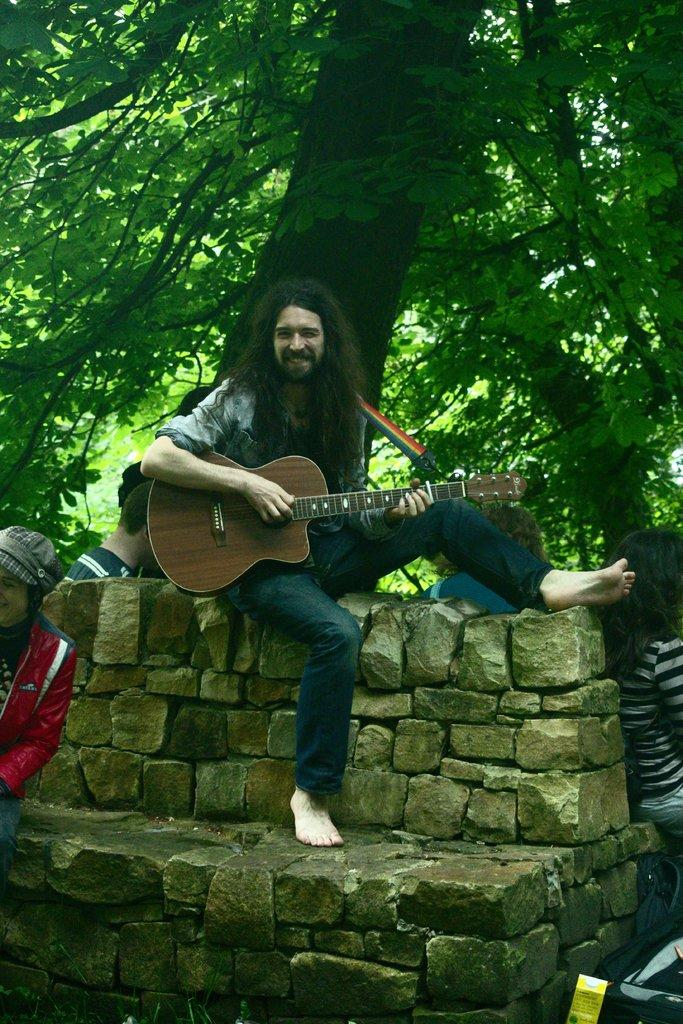What is the person in the image doing? The person is playing a guitar. What type of clothing is the person wearing? The person is wearing black jeans. Where is the person sitting in the image? The person is sitting on a stone wall. Are there any other people in the image? Yes, there is a group of people around the person. What can be seen in the background of the image? There is a green tree in the background of the image. What type of locket is the person wearing around their neck in the image? There is no locket visible around the person's neck in the image. Is the person playing basketball in the image? No, the person is playing a guitar, not basketball, in the image. 